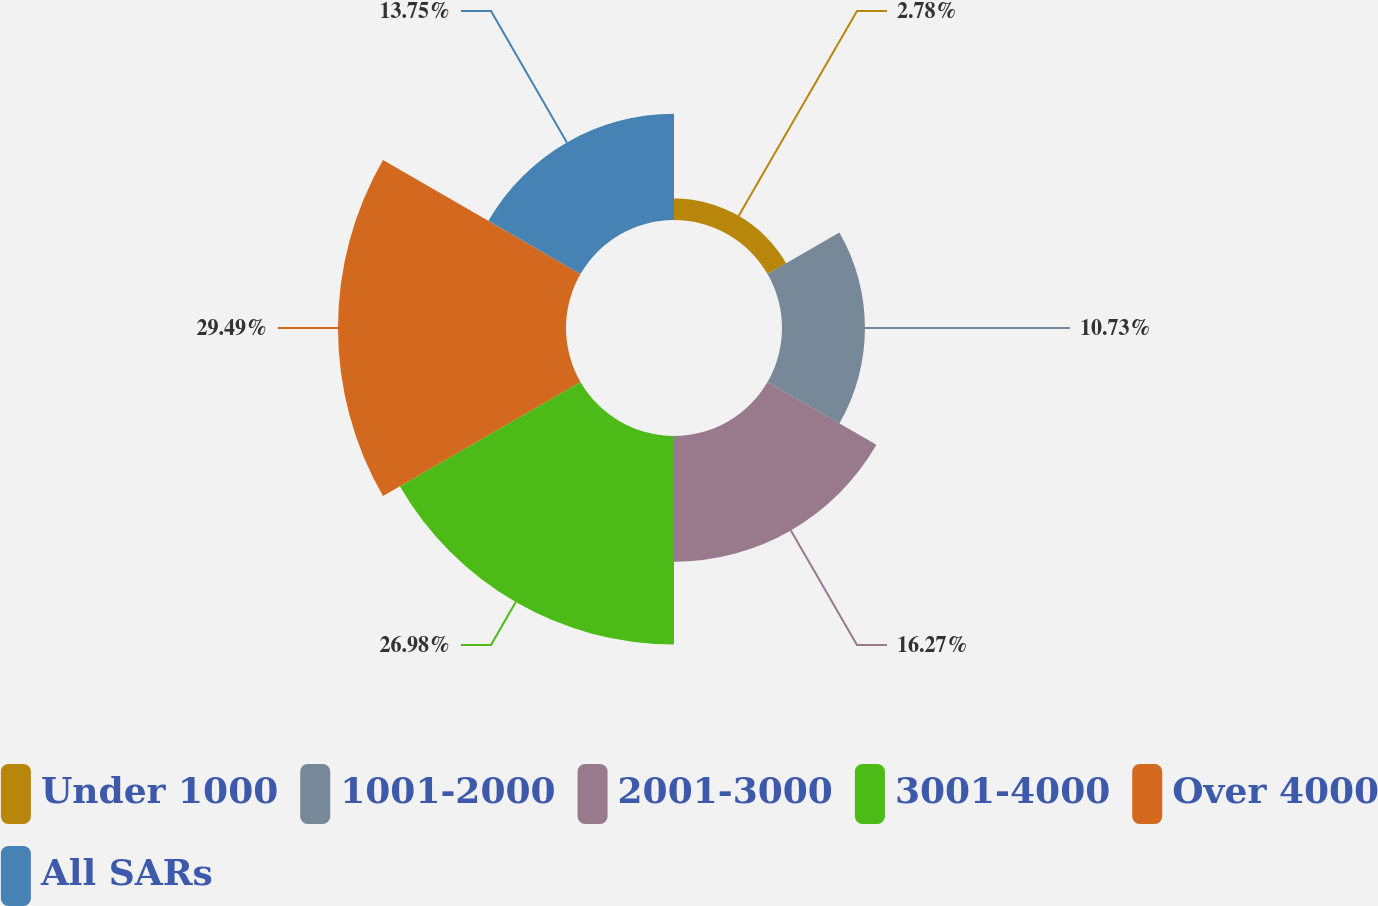Convert chart. <chart><loc_0><loc_0><loc_500><loc_500><pie_chart><fcel>Under 1000<fcel>1001-2000<fcel>2001-3000<fcel>3001-4000<fcel>Over 4000<fcel>All SARs<nl><fcel>2.78%<fcel>10.73%<fcel>16.27%<fcel>26.98%<fcel>29.5%<fcel>13.75%<nl></chart> 